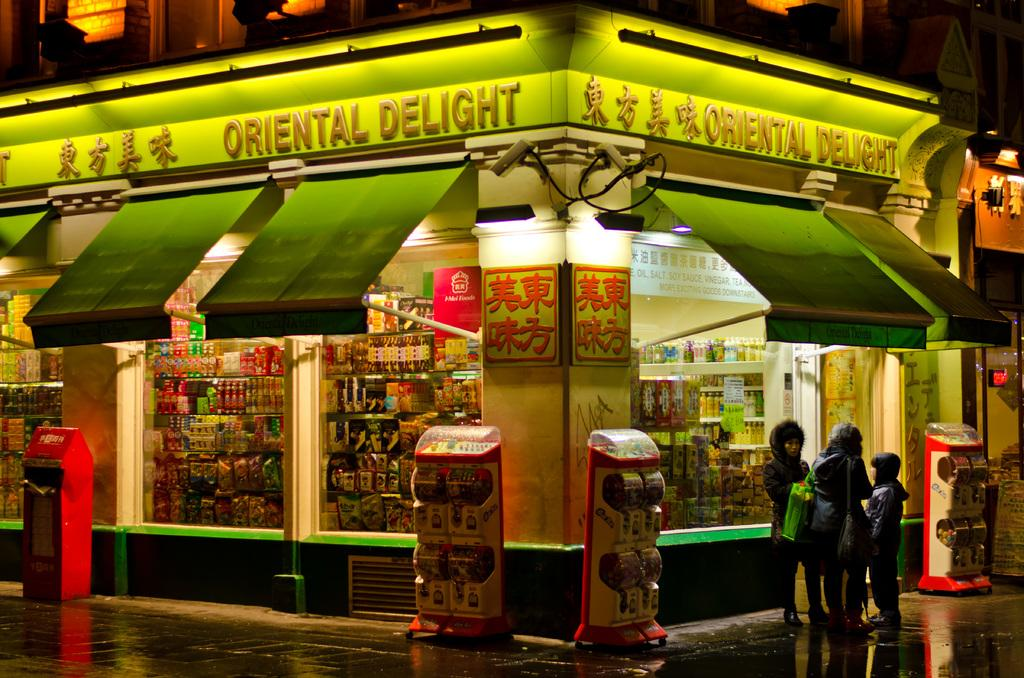<image>
Give a short and clear explanation of the subsequent image. people standing outside of the oriental delight store at night 